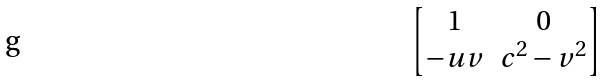Convert formula to latex. <formula><loc_0><loc_0><loc_500><loc_500>\begin{bmatrix} 1 & 0 \\ - u v & c ^ { 2 } - v ^ { 2 } \end{bmatrix}</formula> 